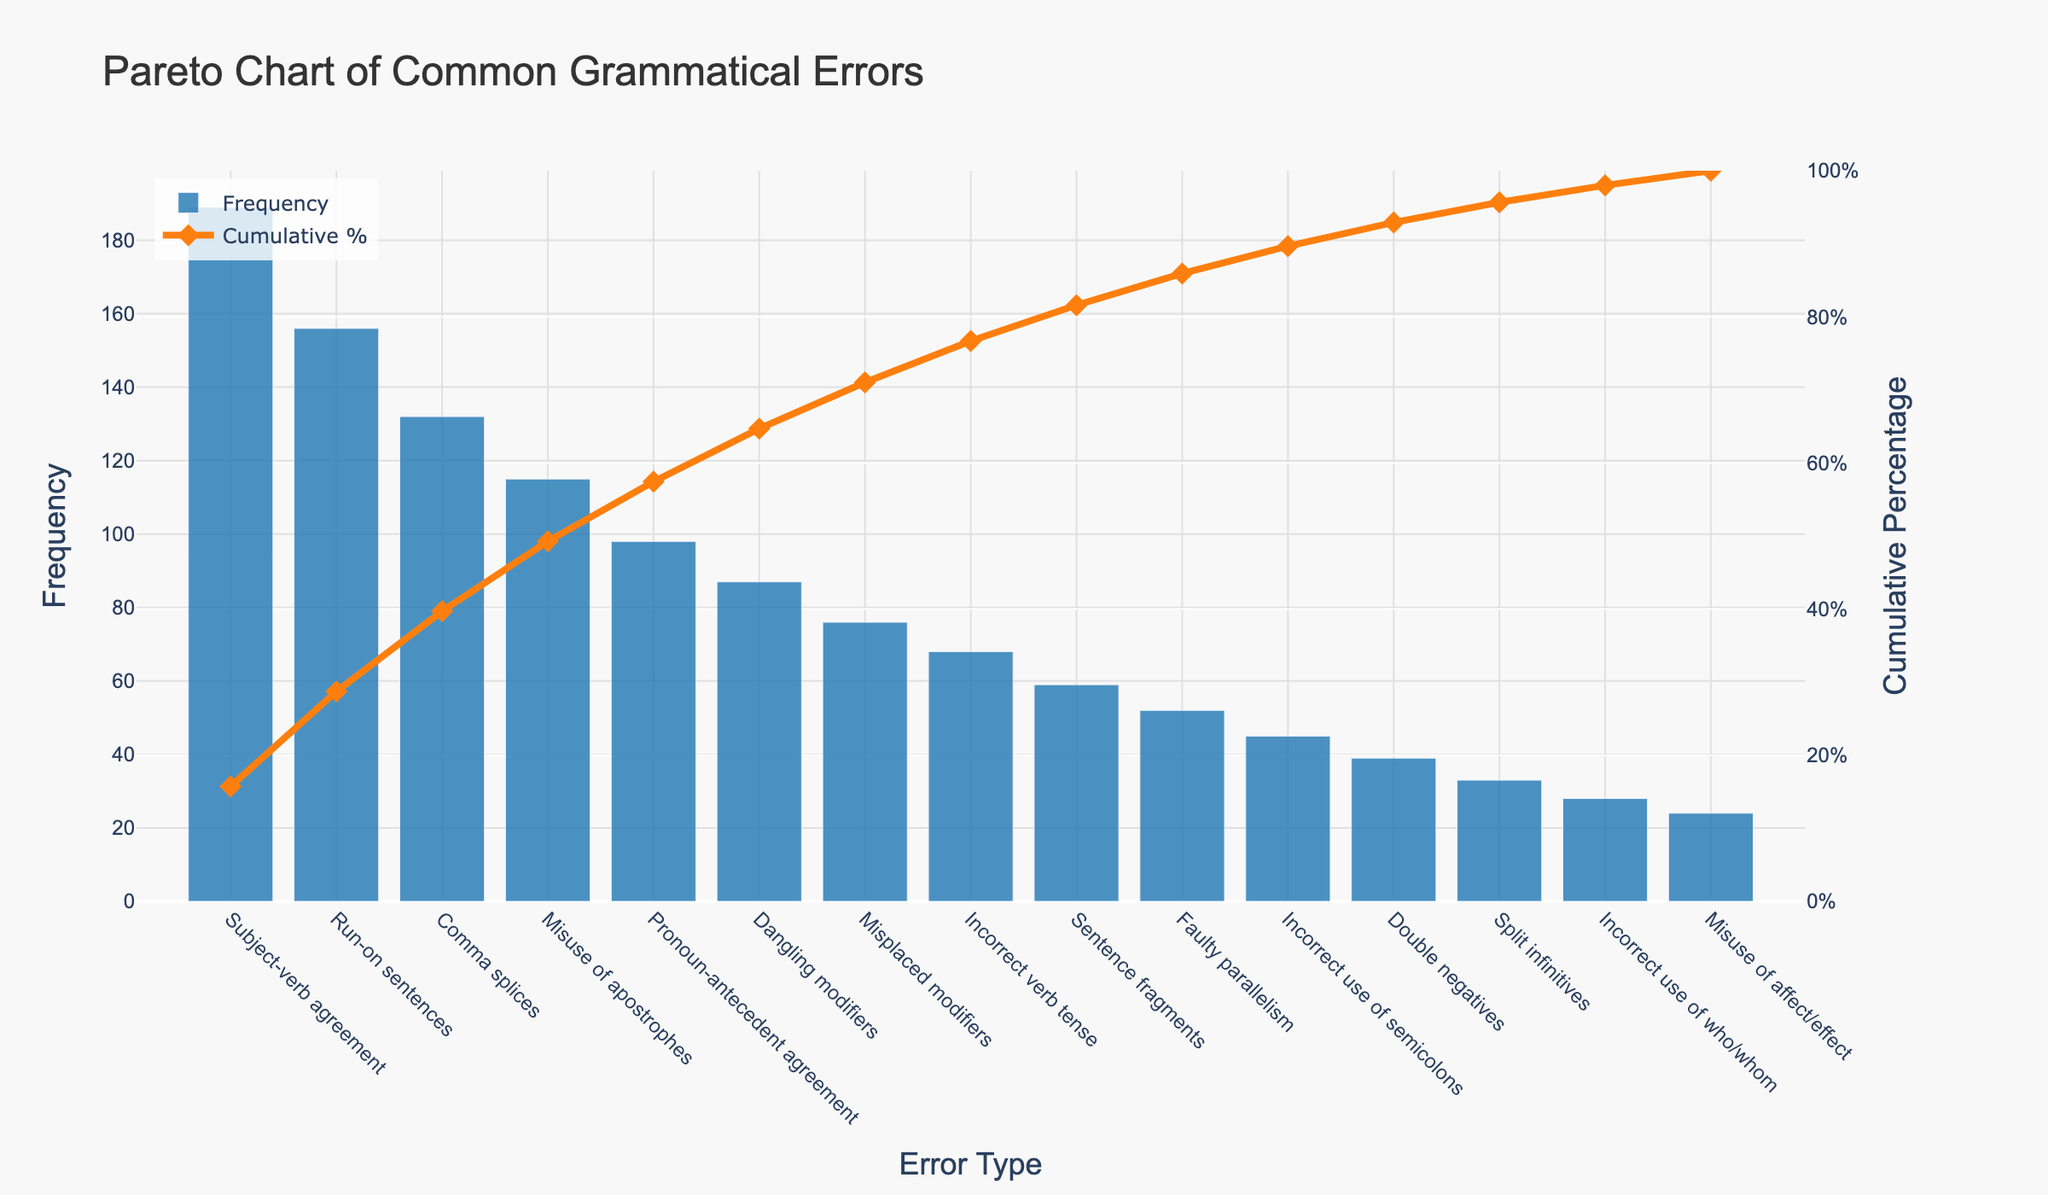Which error has the highest frequency? From the Pareto chart, the bar that reaches the highest point represents the error with the highest frequency. The title above the bar shows "Subject-verb agreement" with a frequency of 189.
Answer: Subject-verb agreement What is the cumulative percentage for the "Run-on sentences" error? In the Pareto chart, you can trace the cumulative percentage line (orange line) directly above the "Run-on sentences" label on the x-axis. The cumulative percentage for this error type is explicitly labeled.
Answer: Approximately 36.3% How many errors occur with more than 100 times of frequency? Identify the bars with a height corresponding to a frequency greater than 100. The bars for "Subject-verb agreement," "Run-on sentences," "Comma splices," and "Misuse of apostrophes" meet this criterion.
Answer: 4 What's the frequency difference between "Incorrect verb tense" and "Sentence fragments"? Refer to the heights of the bars for "Incorrect verb tense" and "Sentence fragments" on the chart. Subtract the frequency of "Incorrect verb tense" (68) from "Sentence fragments" (59). The difference is 68 - 59.
Answer: 9 What percentage of errors are accounted for by the top three most frequent errors? The top three errors are "Subject-verb agreement," "Run-on sentences," and "Comma splices." Summing their frequencies gives 189 + 156 + 132 = 477. To find the percentage, divide by the total number of errors (1161) and multiply by 100: (477/1161) * 100.
Answer: Approximately 41.1% Which error type has a cumulative percentage approaching 50% on the chart? Follow the cumulative percentage line (orange line) and see where it approaches 50% on the x-axis. Around the "Misuse of apostrophes" error label, the cumulative percentage is close to 50%.
Answer: Misuse of apostrophes How do the frequencies of "Dangling modifiers" and "Misplaced modifiers" compare? Locate the bars for "Dangling modifiers" and "Misplaced modifiers." The frequency of "Dangling modifiers" is 87 and the frequency of "Misplaced modifiers" is 76. Compare the two values.
Answer: Dangling modifiers have a higher frequency What cumulative percentage do the errors "Double negatives" and "Split infinitives" collectively fall under? First, find the frequencies of "Double negatives" (39) and "Split infinitives" (33). Add these frequencies together: 39 + 33 = 72. Add these to the cumulative frequencies up to "Double negatives", as "Double negatives" and "Split infinitives" are adjacent in order. Note the cumulative percentage just before "Misuse of affect/effect."
Answer: Approximately 96.2% What type of error marks the threshold crossing the 80% cumulative percentage? Trace the cumulative percentage line (orange line) to find when it first crosses the 80% mark on the y-axis. The type of error beneath this intersection point is "Double negatives."
Answer: Double negatives 